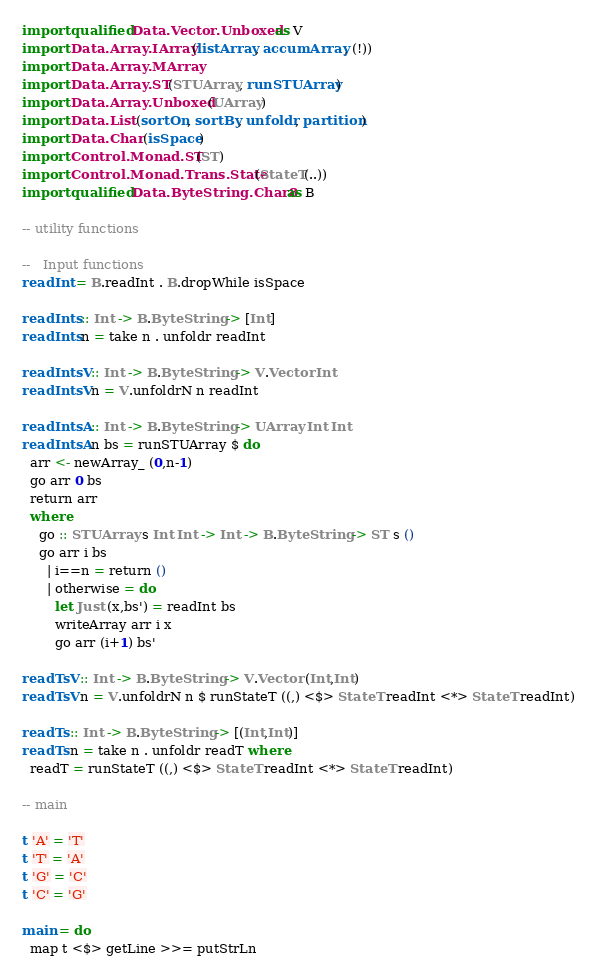<code> <loc_0><loc_0><loc_500><loc_500><_Haskell_>
import qualified Data.Vector.Unboxed as V
import Data.Array.IArray (listArray, accumArray, (!))
import Data.Array.MArray
import Data.Array.ST (STUArray, runSTUArray)
import Data.Array.Unboxed (UArray)
import Data.List (sortOn, sortBy, unfoldr, partition)
import Data.Char (isSpace)
import Control.Monad.ST (ST)
import Control.Monad.Trans.State (StateT(..))
import qualified Data.ByteString.Char8 as B

-- utility functions

--   Input functions
readInt = B.readInt . B.dropWhile isSpace

readInts :: Int -> B.ByteString -> [Int]
readInts n = take n . unfoldr readInt

readIntsV :: Int -> B.ByteString -> V.Vector Int
readIntsV n = V.unfoldrN n readInt

readIntsA :: Int -> B.ByteString -> UArray Int Int
readIntsA n bs = runSTUArray $ do
  arr <- newArray_ (0,n-1)
  go arr 0 bs
  return arr
  where
    go :: STUArray s Int Int -> Int -> B.ByteString -> ST s ()
    go arr i bs
      | i==n = return ()
      | otherwise = do
        let Just (x,bs') = readInt bs
        writeArray arr i x
        go arr (i+1) bs'

readTsV :: Int -> B.ByteString -> V.Vector (Int,Int)
readTsV n = V.unfoldrN n $ runStateT ((,) <$> StateT readInt <*> StateT readInt)

readTs :: Int -> B.ByteString -> [(Int,Int)]
readTs n = take n . unfoldr readT where
  readT = runStateT ((,) <$> StateT readInt <*> StateT readInt)

-- main

t 'A' = 'T'
t 'T' = 'A'
t 'G' = 'C'
t 'C' = 'G'

main = do
  map t <$> getLine >>= putStrLn
</code> 